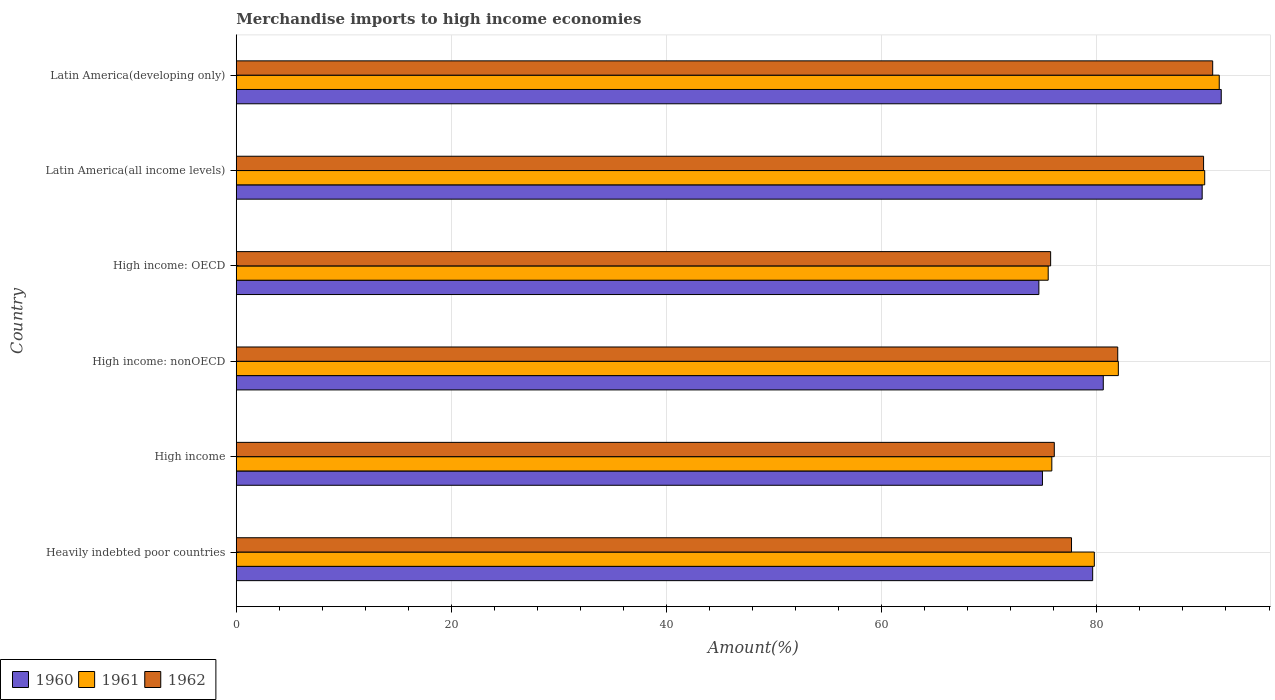How many different coloured bars are there?
Your answer should be very brief. 3. What is the label of the 5th group of bars from the top?
Make the answer very short. High income. In how many cases, is the number of bars for a given country not equal to the number of legend labels?
Ensure brevity in your answer.  0. What is the percentage of amount earned from merchandise imports in 1961 in High income?
Offer a terse response. 75.81. Across all countries, what is the maximum percentage of amount earned from merchandise imports in 1960?
Provide a short and direct response. 91.56. Across all countries, what is the minimum percentage of amount earned from merchandise imports in 1962?
Your response must be concise. 75.7. In which country was the percentage of amount earned from merchandise imports in 1961 maximum?
Ensure brevity in your answer.  Latin America(developing only). In which country was the percentage of amount earned from merchandise imports in 1962 minimum?
Offer a terse response. High income: OECD. What is the total percentage of amount earned from merchandise imports in 1961 in the graph?
Your answer should be very brief. 494.44. What is the difference between the percentage of amount earned from merchandise imports in 1960 in Heavily indebted poor countries and that in Latin America(all income levels)?
Provide a succinct answer. -10.18. What is the difference between the percentage of amount earned from merchandise imports in 1960 in High income and the percentage of amount earned from merchandise imports in 1961 in Latin America(developing only)?
Give a very brief answer. -16.43. What is the average percentage of amount earned from merchandise imports in 1961 per country?
Offer a very short reply. 82.41. What is the difference between the percentage of amount earned from merchandise imports in 1960 and percentage of amount earned from merchandise imports in 1962 in Latin America(developing only)?
Your response must be concise. 0.79. In how many countries, is the percentage of amount earned from merchandise imports in 1961 greater than 36 %?
Keep it short and to the point. 6. What is the ratio of the percentage of amount earned from merchandise imports in 1962 in Heavily indebted poor countries to that in High income?
Keep it short and to the point. 1.02. Is the percentage of amount earned from merchandise imports in 1960 in Heavily indebted poor countries less than that in Latin America(all income levels)?
Your response must be concise. Yes. Is the difference between the percentage of amount earned from merchandise imports in 1960 in High income: nonOECD and Latin America(all income levels) greater than the difference between the percentage of amount earned from merchandise imports in 1962 in High income: nonOECD and Latin America(all income levels)?
Keep it short and to the point. No. What is the difference between the highest and the second highest percentage of amount earned from merchandise imports in 1960?
Your answer should be compact. 1.77. What is the difference between the highest and the lowest percentage of amount earned from merchandise imports in 1962?
Keep it short and to the point. 15.06. What does the 1st bar from the top in Heavily indebted poor countries represents?
Provide a succinct answer. 1962. What does the 1st bar from the bottom in High income: OECD represents?
Offer a terse response. 1960. Are all the bars in the graph horizontal?
Provide a succinct answer. Yes. How many countries are there in the graph?
Give a very brief answer. 6. Where does the legend appear in the graph?
Provide a succinct answer. Bottom left. How are the legend labels stacked?
Your answer should be very brief. Horizontal. What is the title of the graph?
Your response must be concise. Merchandise imports to high income economies. Does "1969" appear as one of the legend labels in the graph?
Your response must be concise. No. What is the label or title of the X-axis?
Offer a very short reply. Amount(%). What is the Amount(%) in 1960 in Heavily indebted poor countries?
Offer a terse response. 79.61. What is the Amount(%) in 1961 in Heavily indebted poor countries?
Ensure brevity in your answer.  79.76. What is the Amount(%) of 1962 in Heavily indebted poor countries?
Offer a terse response. 77.64. What is the Amount(%) in 1960 in High income?
Provide a succinct answer. 74.94. What is the Amount(%) of 1961 in High income?
Make the answer very short. 75.81. What is the Amount(%) in 1962 in High income?
Make the answer very short. 76.04. What is the Amount(%) of 1960 in High income: nonOECD?
Your response must be concise. 80.59. What is the Amount(%) in 1961 in High income: nonOECD?
Offer a very short reply. 81.99. What is the Amount(%) in 1962 in High income: nonOECD?
Your response must be concise. 81.94. What is the Amount(%) of 1960 in High income: OECD?
Provide a short and direct response. 74.61. What is the Amount(%) in 1961 in High income: OECD?
Offer a very short reply. 75.47. What is the Amount(%) of 1962 in High income: OECD?
Keep it short and to the point. 75.7. What is the Amount(%) in 1960 in Latin America(all income levels)?
Offer a very short reply. 89.79. What is the Amount(%) in 1961 in Latin America(all income levels)?
Provide a succinct answer. 90.02. What is the Amount(%) of 1962 in Latin America(all income levels)?
Ensure brevity in your answer.  89.92. What is the Amount(%) in 1960 in Latin America(developing only)?
Offer a very short reply. 91.56. What is the Amount(%) in 1961 in Latin America(developing only)?
Offer a very short reply. 91.37. What is the Amount(%) in 1962 in Latin America(developing only)?
Make the answer very short. 90.76. Across all countries, what is the maximum Amount(%) in 1960?
Make the answer very short. 91.56. Across all countries, what is the maximum Amount(%) in 1961?
Provide a succinct answer. 91.37. Across all countries, what is the maximum Amount(%) in 1962?
Your response must be concise. 90.76. Across all countries, what is the minimum Amount(%) of 1960?
Give a very brief answer. 74.61. Across all countries, what is the minimum Amount(%) of 1961?
Ensure brevity in your answer.  75.47. Across all countries, what is the minimum Amount(%) of 1962?
Your answer should be very brief. 75.7. What is the total Amount(%) of 1960 in the graph?
Offer a terse response. 491.09. What is the total Amount(%) in 1961 in the graph?
Provide a short and direct response. 494.44. What is the total Amount(%) of 1962 in the graph?
Your answer should be very brief. 492. What is the difference between the Amount(%) of 1960 in Heavily indebted poor countries and that in High income?
Keep it short and to the point. 4.67. What is the difference between the Amount(%) of 1961 in Heavily indebted poor countries and that in High income?
Your answer should be compact. 3.95. What is the difference between the Amount(%) of 1962 in Heavily indebted poor countries and that in High income?
Your answer should be compact. 1.6. What is the difference between the Amount(%) in 1960 in Heavily indebted poor countries and that in High income: nonOECD?
Keep it short and to the point. -0.99. What is the difference between the Amount(%) of 1961 in Heavily indebted poor countries and that in High income: nonOECD?
Give a very brief answer. -2.23. What is the difference between the Amount(%) of 1962 in Heavily indebted poor countries and that in High income: nonOECD?
Keep it short and to the point. -4.3. What is the difference between the Amount(%) in 1960 in Heavily indebted poor countries and that in High income: OECD?
Give a very brief answer. 5. What is the difference between the Amount(%) in 1961 in Heavily indebted poor countries and that in High income: OECD?
Ensure brevity in your answer.  4.29. What is the difference between the Amount(%) of 1962 in Heavily indebted poor countries and that in High income: OECD?
Your answer should be very brief. 1.94. What is the difference between the Amount(%) of 1960 in Heavily indebted poor countries and that in Latin America(all income levels)?
Provide a short and direct response. -10.18. What is the difference between the Amount(%) of 1961 in Heavily indebted poor countries and that in Latin America(all income levels)?
Your response must be concise. -10.26. What is the difference between the Amount(%) in 1962 in Heavily indebted poor countries and that in Latin America(all income levels)?
Your response must be concise. -12.28. What is the difference between the Amount(%) in 1960 in Heavily indebted poor countries and that in Latin America(developing only)?
Give a very brief answer. -11.95. What is the difference between the Amount(%) of 1961 in Heavily indebted poor countries and that in Latin America(developing only)?
Offer a very short reply. -11.61. What is the difference between the Amount(%) in 1962 in Heavily indebted poor countries and that in Latin America(developing only)?
Provide a short and direct response. -13.12. What is the difference between the Amount(%) in 1960 in High income and that in High income: nonOECD?
Keep it short and to the point. -5.65. What is the difference between the Amount(%) of 1961 in High income and that in High income: nonOECD?
Provide a short and direct response. -6.18. What is the difference between the Amount(%) in 1962 in High income and that in High income: nonOECD?
Offer a terse response. -5.9. What is the difference between the Amount(%) in 1960 in High income and that in High income: OECD?
Ensure brevity in your answer.  0.33. What is the difference between the Amount(%) of 1961 in High income and that in High income: OECD?
Provide a short and direct response. 0.34. What is the difference between the Amount(%) of 1962 in High income and that in High income: OECD?
Offer a very short reply. 0.34. What is the difference between the Amount(%) of 1960 in High income and that in Latin America(all income levels)?
Offer a very short reply. -14.85. What is the difference between the Amount(%) of 1961 in High income and that in Latin America(all income levels)?
Your answer should be compact. -14.21. What is the difference between the Amount(%) in 1962 in High income and that in Latin America(all income levels)?
Ensure brevity in your answer.  -13.88. What is the difference between the Amount(%) of 1960 in High income and that in Latin America(developing only)?
Ensure brevity in your answer.  -16.62. What is the difference between the Amount(%) in 1961 in High income and that in Latin America(developing only)?
Keep it short and to the point. -15.56. What is the difference between the Amount(%) in 1962 in High income and that in Latin America(developing only)?
Make the answer very short. -14.72. What is the difference between the Amount(%) of 1960 in High income: nonOECD and that in High income: OECD?
Make the answer very short. 5.99. What is the difference between the Amount(%) of 1961 in High income: nonOECD and that in High income: OECD?
Provide a short and direct response. 6.52. What is the difference between the Amount(%) of 1962 in High income: nonOECD and that in High income: OECD?
Provide a succinct answer. 6.24. What is the difference between the Amount(%) in 1960 in High income: nonOECD and that in Latin America(all income levels)?
Keep it short and to the point. -9.19. What is the difference between the Amount(%) of 1961 in High income: nonOECD and that in Latin America(all income levels)?
Your answer should be compact. -8.03. What is the difference between the Amount(%) in 1962 in High income: nonOECD and that in Latin America(all income levels)?
Your answer should be compact. -7.98. What is the difference between the Amount(%) in 1960 in High income: nonOECD and that in Latin America(developing only)?
Your answer should be compact. -10.97. What is the difference between the Amount(%) in 1961 in High income: nonOECD and that in Latin America(developing only)?
Provide a short and direct response. -9.38. What is the difference between the Amount(%) of 1962 in High income: nonOECD and that in Latin America(developing only)?
Keep it short and to the point. -8.83. What is the difference between the Amount(%) in 1960 in High income: OECD and that in Latin America(all income levels)?
Offer a very short reply. -15.18. What is the difference between the Amount(%) of 1961 in High income: OECD and that in Latin America(all income levels)?
Ensure brevity in your answer.  -14.55. What is the difference between the Amount(%) of 1962 in High income: OECD and that in Latin America(all income levels)?
Keep it short and to the point. -14.22. What is the difference between the Amount(%) of 1960 in High income: OECD and that in Latin America(developing only)?
Give a very brief answer. -16.95. What is the difference between the Amount(%) in 1961 in High income: OECD and that in Latin America(developing only)?
Your answer should be very brief. -15.9. What is the difference between the Amount(%) of 1962 in High income: OECD and that in Latin America(developing only)?
Your response must be concise. -15.06. What is the difference between the Amount(%) of 1960 in Latin America(all income levels) and that in Latin America(developing only)?
Your answer should be very brief. -1.77. What is the difference between the Amount(%) of 1961 in Latin America(all income levels) and that in Latin America(developing only)?
Offer a very short reply. -1.35. What is the difference between the Amount(%) of 1962 in Latin America(all income levels) and that in Latin America(developing only)?
Offer a terse response. -0.85. What is the difference between the Amount(%) of 1960 in Heavily indebted poor countries and the Amount(%) of 1961 in High income?
Offer a very short reply. 3.8. What is the difference between the Amount(%) in 1960 in Heavily indebted poor countries and the Amount(%) in 1962 in High income?
Offer a very short reply. 3.57. What is the difference between the Amount(%) in 1961 in Heavily indebted poor countries and the Amount(%) in 1962 in High income?
Your response must be concise. 3.72. What is the difference between the Amount(%) of 1960 in Heavily indebted poor countries and the Amount(%) of 1961 in High income: nonOECD?
Provide a succinct answer. -2.39. What is the difference between the Amount(%) of 1960 in Heavily indebted poor countries and the Amount(%) of 1962 in High income: nonOECD?
Your answer should be very brief. -2.33. What is the difference between the Amount(%) in 1961 in Heavily indebted poor countries and the Amount(%) in 1962 in High income: nonOECD?
Make the answer very short. -2.18. What is the difference between the Amount(%) of 1960 in Heavily indebted poor countries and the Amount(%) of 1961 in High income: OECD?
Your answer should be very brief. 4.13. What is the difference between the Amount(%) of 1960 in Heavily indebted poor countries and the Amount(%) of 1962 in High income: OECD?
Provide a succinct answer. 3.91. What is the difference between the Amount(%) of 1961 in Heavily indebted poor countries and the Amount(%) of 1962 in High income: OECD?
Make the answer very short. 4.06. What is the difference between the Amount(%) in 1960 in Heavily indebted poor countries and the Amount(%) in 1961 in Latin America(all income levels)?
Your answer should be very brief. -10.41. What is the difference between the Amount(%) in 1960 in Heavily indebted poor countries and the Amount(%) in 1962 in Latin America(all income levels)?
Your answer should be compact. -10.31. What is the difference between the Amount(%) in 1961 in Heavily indebted poor countries and the Amount(%) in 1962 in Latin America(all income levels)?
Give a very brief answer. -10.16. What is the difference between the Amount(%) in 1960 in Heavily indebted poor countries and the Amount(%) in 1961 in Latin America(developing only)?
Give a very brief answer. -11.77. What is the difference between the Amount(%) in 1960 in Heavily indebted poor countries and the Amount(%) in 1962 in Latin America(developing only)?
Ensure brevity in your answer.  -11.16. What is the difference between the Amount(%) in 1961 in Heavily indebted poor countries and the Amount(%) in 1962 in Latin America(developing only)?
Ensure brevity in your answer.  -11. What is the difference between the Amount(%) in 1960 in High income and the Amount(%) in 1961 in High income: nonOECD?
Your response must be concise. -7.05. What is the difference between the Amount(%) in 1960 in High income and the Amount(%) in 1962 in High income: nonOECD?
Provide a short and direct response. -7. What is the difference between the Amount(%) in 1961 in High income and the Amount(%) in 1962 in High income: nonOECD?
Give a very brief answer. -6.13. What is the difference between the Amount(%) in 1960 in High income and the Amount(%) in 1961 in High income: OECD?
Your answer should be very brief. -0.53. What is the difference between the Amount(%) in 1960 in High income and the Amount(%) in 1962 in High income: OECD?
Keep it short and to the point. -0.76. What is the difference between the Amount(%) of 1961 in High income and the Amount(%) of 1962 in High income: OECD?
Give a very brief answer. 0.11. What is the difference between the Amount(%) of 1960 in High income and the Amount(%) of 1961 in Latin America(all income levels)?
Provide a succinct answer. -15.08. What is the difference between the Amount(%) of 1960 in High income and the Amount(%) of 1962 in Latin America(all income levels)?
Provide a succinct answer. -14.98. What is the difference between the Amount(%) in 1961 in High income and the Amount(%) in 1962 in Latin America(all income levels)?
Your answer should be very brief. -14.11. What is the difference between the Amount(%) of 1960 in High income and the Amount(%) of 1961 in Latin America(developing only)?
Provide a short and direct response. -16.43. What is the difference between the Amount(%) in 1960 in High income and the Amount(%) in 1962 in Latin America(developing only)?
Your answer should be compact. -15.82. What is the difference between the Amount(%) of 1961 in High income and the Amount(%) of 1962 in Latin America(developing only)?
Ensure brevity in your answer.  -14.95. What is the difference between the Amount(%) in 1960 in High income: nonOECD and the Amount(%) in 1961 in High income: OECD?
Provide a short and direct response. 5.12. What is the difference between the Amount(%) of 1960 in High income: nonOECD and the Amount(%) of 1962 in High income: OECD?
Give a very brief answer. 4.89. What is the difference between the Amount(%) in 1961 in High income: nonOECD and the Amount(%) in 1962 in High income: OECD?
Ensure brevity in your answer.  6.29. What is the difference between the Amount(%) in 1960 in High income: nonOECD and the Amount(%) in 1961 in Latin America(all income levels)?
Your response must be concise. -9.43. What is the difference between the Amount(%) of 1960 in High income: nonOECD and the Amount(%) of 1962 in Latin America(all income levels)?
Offer a very short reply. -9.32. What is the difference between the Amount(%) in 1961 in High income: nonOECD and the Amount(%) in 1962 in Latin America(all income levels)?
Keep it short and to the point. -7.92. What is the difference between the Amount(%) of 1960 in High income: nonOECD and the Amount(%) of 1961 in Latin America(developing only)?
Offer a terse response. -10.78. What is the difference between the Amount(%) in 1960 in High income: nonOECD and the Amount(%) in 1962 in Latin America(developing only)?
Provide a succinct answer. -10.17. What is the difference between the Amount(%) in 1961 in High income: nonOECD and the Amount(%) in 1962 in Latin America(developing only)?
Your answer should be compact. -8.77. What is the difference between the Amount(%) of 1960 in High income: OECD and the Amount(%) of 1961 in Latin America(all income levels)?
Keep it short and to the point. -15.41. What is the difference between the Amount(%) in 1960 in High income: OECD and the Amount(%) in 1962 in Latin America(all income levels)?
Keep it short and to the point. -15.31. What is the difference between the Amount(%) of 1961 in High income: OECD and the Amount(%) of 1962 in Latin America(all income levels)?
Offer a very short reply. -14.44. What is the difference between the Amount(%) of 1960 in High income: OECD and the Amount(%) of 1961 in Latin America(developing only)?
Make the answer very short. -16.77. What is the difference between the Amount(%) of 1960 in High income: OECD and the Amount(%) of 1962 in Latin America(developing only)?
Offer a very short reply. -16.16. What is the difference between the Amount(%) in 1961 in High income: OECD and the Amount(%) in 1962 in Latin America(developing only)?
Your answer should be compact. -15.29. What is the difference between the Amount(%) in 1960 in Latin America(all income levels) and the Amount(%) in 1961 in Latin America(developing only)?
Provide a short and direct response. -1.59. What is the difference between the Amount(%) of 1960 in Latin America(all income levels) and the Amount(%) of 1962 in Latin America(developing only)?
Your answer should be compact. -0.98. What is the difference between the Amount(%) of 1961 in Latin America(all income levels) and the Amount(%) of 1962 in Latin America(developing only)?
Make the answer very short. -0.74. What is the average Amount(%) in 1960 per country?
Offer a very short reply. 81.85. What is the average Amount(%) of 1961 per country?
Offer a terse response. 82.41. What is the average Amount(%) of 1962 per country?
Your answer should be very brief. 82. What is the difference between the Amount(%) of 1960 and Amount(%) of 1961 in Heavily indebted poor countries?
Provide a short and direct response. -0.15. What is the difference between the Amount(%) of 1960 and Amount(%) of 1962 in Heavily indebted poor countries?
Keep it short and to the point. 1.97. What is the difference between the Amount(%) of 1961 and Amount(%) of 1962 in Heavily indebted poor countries?
Offer a terse response. 2.12. What is the difference between the Amount(%) of 1960 and Amount(%) of 1961 in High income?
Offer a terse response. -0.87. What is the difference between the Amount(%) of 1960 and Amount(%) of 1962 in High income?
Your response must be concise. -1.1. What is the difference between the Amount(%) in 1961 and Amount(%) in 1962 in High income?
Ensure brevity in your answer.  -0.23. What is the difference between the Amount(%) in 1960 and Amount(%) in 1961 in High income: nonOECD?
Offer a terse response. -1.4. What is the difference between the Amount(%) of 1960 and Amount(%) of 1962 in High income: nonOECD?
Keep it short and to the point. -1.34. What is the difference between the Amount(%) in 1961 and Amount(%) in 1962 in High income: nonOECD?
Ensure brevity in your answer.  0.06. What is the difference between the Amount(%) in 1960 and Amount(%) in 1961 in High income: OECD?
Your answer should be compact. -0.87. What is the difference between the Amount(%) in 1960 and Amount(%) in 1962 in High income: OECD?
Give a very brief answer. -1.09. What is the difference between the Amount(%) in 1961 and Amount(%) in 1962 in High income: OECD?
Provide a short and direct response. -0.23. What is the difference between the Amount(%) of 1960 and Amount(%) of 1961 in Latin America(all income levels)?
Ensure brevity in your answer.  -0.23. What is the difference between the Amount(%) of 1960 and Amount(%) of 1962 in Latin America(all income levels)?
Give a very brief answer. -0.13. What is the difference between the Amount(%) of 1961 and Amount(%) of 1962 in Latin America(all income levels)?
Offer a terse response. 0.1. What is the difference between the Amount(%) in 1960 and Amount(%) in 1961 in Latin America(developing only)?
Provide a short and direct response. 0.19. What is the difference between the Amount(%) in 1960 and Amount(%) in 1962 in Latin America(developing only)?
Offer a very short reply. 0.79. What is the difference between the Amount(%) in 1961 and Amount(%) in 1962 in Latin America(developing only)?
Keep it short and to the point. 0.61. What is the ratio of the Amount(%) of 1960 in Heavily indebted poor countries to that in High income?
Make the answer very short. 1.06. What is the ratio of the Amount(%) in 1961 in Heavily indebted poor countries to that in High income?
Your response must be concise. 1.05. What is the ratio of the Amount(%) in 1962 in Heavily indebted poor countries to that in High income?
Your answer should be very brief. 1.02. What is the ratio of the Amount(%) in 1960 in Heavily indebted poor countries to that in High income: nonOECD?
Your answer should be compact. 0.99. What is the ratio of the Amount(%) of 1961 in Heavily indebted poor countries to that in High income: nonOECD?
Your response must be concise. 0.97. What is the ratio of the Amount(%) of 1962 in Heavily indebted poor countries to that in High income: nonOECD?
Keep it short and to the point. 0.95. What is the ratio of the Amount(%) in 1960 in Heavily indebted poor countries to that in High income: OECD?
Offer a terse response. 1.07. What is the ratio of the Amount(%) in 1961 in Heavily indebted poor countries to that in High income: OECD?
Your answer should be very brief. 1.06. What is the ratio of the Amount(%) of 1962 in Heavily indebted poor countries to that in High income: OECD?
Keep it short and to the point. 1.03. What is the ratio of the Amount(%) of 1960 in Heavily indebted poor countries to that in Latin America(all income levels)?
Give a very brief answer. 0.89. What is the ratio of the Amount(%) of 1961 in Heavily indebted poor countries to that in Latin America(all income levels)?
Your response must be concise. 0.89. What is the ratio of the Amount(%) of 1962 in Heavily indebted poor countries to that in Latin America(all income levels)?
Make the answer very short. 0.86. What is the ratio of the Amount(%) in 1960 in Heavily indebted poor countries to that in Latin America(developing only)?
Give a very brief answer. 0.87. What is the ratio of the Amount(%) of 1961 in Heavily indebted poor countries to that in Latin America(developing only)?
Your answer should be very brief. 0.87. What is the ratio of the Amount(%) of 1962 in Heavily indebted poor countries to that in Latin America(developing only)?
Provide a succinct answer. 0.86. What is the ratio of the Amount(%) in 1960 in High income to that in High income: nonOECD?
Ensure brevity in your answer.  0.93. What is the ratio of the Amount(%) of 1961 in High income to that in High income: nonOECD?
Your answer should be compact. 0.92. What is the ratio of the Amount(%) of 1962 in High income to that in High income: nonOECD?
Provide a succinct answer. 0.93. What is the ratio of the Amount(%) of 1960 in High income to that in High income: OECD?
Offer a very short reply. 1. What is the ratio of the Amount(%) of 1962 in High income to that in High income: OECD?
Your answer should be compact. 1. What is the ratio of the Amount(%) in 1960 in High income to that in Latin America(all income levels)?
Offer a very short reply. 0.83. What is the ratio of the Amount(%) in 1961 in High income to that in Latin America(all income levels)?
Offer a terse response. 0.84. What is the ratio of the Amount(%) of 1962 in High income to that in Latin America(all income levels)?
Your answer should be compact. 0.85. What is the ratio of the Amount(%) of 1960 in High income to that in Latin America(developing only)?
Your answer should be very brief. 0.82. What is the ratio of the Amount(%) of 1961 in High income to that in Latin America(developing only)?
Provide a succinct answer. 0.83. What is the ratio of the Amount(%) in 1962 in High income to that in Latin America(developing only)?
Offer a terse response. 0.84. What is the ratio of the Amount(%) of 1960 in High income: nonOECD to that in High income: OECD?
Provide a succinct answer. 1.08. What is the ratio of the Amount(%) of 1961 in High income: nonOECD to that in High income: OECD?
Provide a short and direct response. 1.09. What is the ratio of the Amount(%) in 1962 in High income: nonOECD to that in High income: OECD?
Offer a terse response. 1.08. What is the ratio of the Amount(%) of 1960 in High income: nonOECD to that in Latin America(all income levels)?
Make the answer very short. 0.9. What is the ratio of the Amount(%) of 1961 in High income: nonOECD to that in Latin America(all income levels)?
Offer a terse response. 0.91. What is the ratio of the Amount(%) in 1962 in High income: nonOECD to that in Latin America(all income levels)?
Provide a short and direct response. 0.91. What is the ratio of the Amount(%) in 1960 in High income: nonOECD to that in Latin America(developing only)?
Your response must be concise. 0.88. What is the ratio of the Amount(%) of 1961 in High income: nonOECD to that in Latin America(developing only)?
Provide a short and direct response. 0.9. What is the ratio of the Amount(%) in 1962 in High income: nonOECD to that in Latin America(developing only)?
Make the answer very short. 0.9. What is the ratio of the Amount(%) of 1960 in High income: OECD to that in Latin America(all income levels)?
Ensure brevity in your answer.  0.83. What is the ratio of the Amount(%) in 1961 in High income: OECD to that in Latin America(all income levels)?
Provide a succinct answer. 0.84. What is the ratio of the Amount(%) in 1962 in High income: OECD to that in Latin America(all income levels)?
Provide a succinct answer. 0.84. What is the ratio of the Amount(%) in 1960 in High income: OECD to that in Latin America(developing only)?
Your answer should be very brief. 0.81. What is the ratio of the Amount(%) in 1961 in High income: OECD to that in Latin America(developing only)?
Your answer should be compact. 0.83. What is the ratio of the Amount(%) in 1962 in High income: OECD to that in Latin America(developing only)?
Provide a succinct answer. 0.83. What is the ratio of the Amount(%) in 1960 in Latin America(all income levels) to that in Latin America(developing only)?
Provide a short and direct response. 0.98. What is the ratio of the Amount(%) of 1961 in Latin America(all income levels) to that in Latin America(developing only)?
Your response must be concise. 0.99. What is the ratio of the Amount(%) of 1962 in Latin America(all income levels) to that in Latin America(developing only)?
Offer a very short reply. 0.99. What is the difference between the highest and the second highest Amount(%) in 1960?
Give a very brief answer. 1.77. What is the difference between the highest and the second highest Amount(%) in 1961?
Keep it short and to the point. 1.35. What is the difference between the highest and the second highest Amount(%) in 1962?
Keep it short and to the point. 0.85. What is the difference between the highest and the lowest Amount(%) in 1960?
Your answer should be very brief. 16.95. What is the difference between the highest and the lowest Amount(%) of 1961?
Make the answer very short. 15.9. What is the difference between the highest and the lowest Amount(%) of 1962?
Your answer should be very brief. 15.06. 